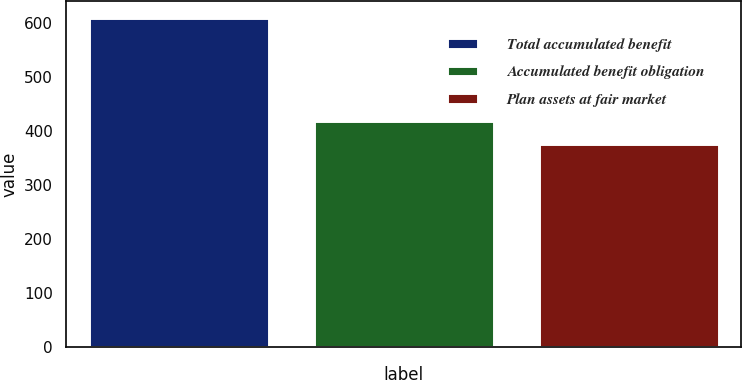Convert chart to OTSL. <chart><loc_0><loc_0><loc_500><loc_500><bar_chart><fcel>Total accumulated benefit<fcel>Accumulated benefit obligation<fcel>Plan assets at fair market<nl><fcel>609.1<fcel>417.4<fcel>375.5<nl></chart> 